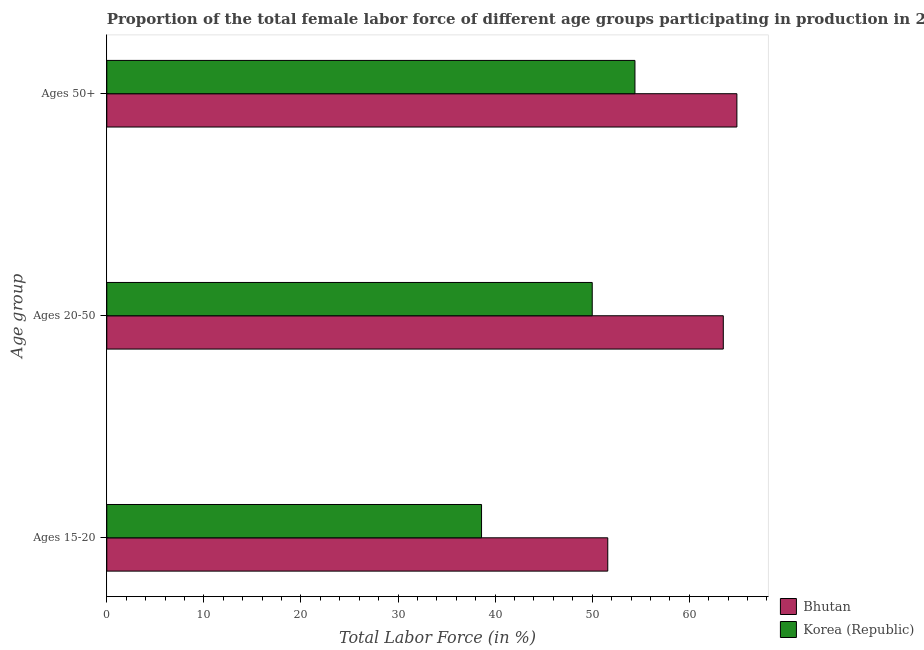How many groups of bars are there?
Your response must be concise. 3. Are the number of bars on each tick of the Y-axis equal?
Your answer should be very brief. Yes. What is the label of the 1st group of bars from the top?
Ensure brevity in your answer.  Ages 50+. What is the percentage of female labor force within the age group 20-50 in Bhutan?
Provide a succinct answer. 63.5. Across all countries, what is the maximum percentage of female labor force above age 50?
Your response must be concise. 64.9. Across all countries, what is the minimum percentage of female labor force above age 50?
Give a very brief answer. 54.4. In which country was the percentage of female labor force within the age group 15-20 maximum?
Provide a succinct answer. Bhutan. What is the total percentage of female labor force within the age group 20-50 in the graph?
Keep it short and to the point. 113.5. What is the difference between the percentage of female labor force within the age group 20-50 in Bhutan and that in Korea (Republic)?
Offer a terse response. 13.5. What is the difference between the percentage of female labor force within the age group 20-50 in Korea (Republic) and the percentage of female labor force above age 50 in Bhutan?
Make the answer very short. -14.9. What is the average percentage of female labor force above age 50 per country?
Ensure brevity in your answer.  59.65. What is the difference between the percentage of female labor force within the age group 15-20 and percentage of female labor force above age 50 in Korea (Republic)?
Make the answer very short. -15.8. What is the ratio of the percentage of female labor force within the age group 15-20 in Bhutan to that in Korea (Republic)?
Keep it short and to the point. 1.34. What is the difference between the highest and the second highest percentage of female labor force within the age group 20-50?
Offer a very short reply. 13.5. What is the difference between the highest and the lowest percentage of female labor force within the age group 15-20?
Offer a terse response. 13. Is the sum of the percentage of female labor force within the age group 20-50 in Bhutan and Korea (Republic) greater than the maximum percentage of female labor force above age 50 across all countries?
Your answer should be very brief. Yes. What does the 1st bar from the top in Ages 50+ represents?
Offer a very short reply. Korea (Republic). Are all the bars in the graph horizontal?
Ensure brevity in your answer.  Yes. How many legend labels are there?
Your response must be concise. 2. How are the legend labels stacked?
Give a very brief answer. Vertical. What is the title of the graph?
Keep it short and to the point. Proportion of the total female labor force of different age groups participating in production in 2005. Does "Palau" appear as one of the legend labels in the graph?
Provide a short and direct response. No. What is the label or title of the X-axis?
Your answer should be compact. Total Labor Force (in %). What is the label or title of the Y-axis?
Offer a terse response. Age group. What is the Total Labor Force (in %) of Bhutan in Ages 15-20?
Offer a terse response. 51.6. What is the Total Labor Force (in %) of Korea (Republic) in Ages 15-20?
Make the answer very short. 38.6. What is the Total Labor Force (in %) in Bhutan in Ages 20-50?
Keep it short and to the point. 63.5. What is the Total Labor Force (in %) in Korea (Republic) in Ages 20-50?
Provide a short and direct response. 50. What is the Total Labor Force (in %) in Bhutan in Ages 50+?
Offer a very short reply. 64.9. What is the Total Labor Force (in %) of Korea (Republic) in Ages 50+?
Offer a very short reply. 54.4. Across all Age group, what is the maximum Total Labor Force (in %) of Bhutan?
Provide a succinct answer. 64.9. Across all Age group, what is the maximum Total Labor Force (in %) in Korea (Republic)?
Keep it short and to the point. 54.4. Across all Age group, what is the minimum Total Labor Force (in %) of Bhutan?
Your response must be concise. 51.6. Across all Age group, what is the minimum Total Labor Force (in %) of Korea (Republic)?
Make the answer very short. 38.6. What is the total Total Labor Force (in %) of Bhutan in the graph?
Provide a short and direct response. 180. What is the total Total Labor Force (in %) of Korea (Republic) in the graph?
Offer a terse response. 143. What is the difference between the Total Labor Force (in %) in Bhutan in Ages 15-20 and that in Ages 20-50?
Ensure brevity in your answer.  -11.9. What is the difference between the Total Labor Force (in %) in Korea (Republic) in Ages 15-20 and that in Ages 20-50?
Make the answer very short. -11.4. What is the difference between the Total Labor Force (in %) in Bhutan in Ages 15-20 and that in Ages 50+?
Your answer should be very brief. -13.3. What is the difference between the Total Labor Force (in %) of Korea (Republic) in Ages 15-20 and that in Ages 50+?
Your response must be concise. -15.8. What is the difference between the Total Labor Force (in %) in Korea (Republic) in Ages 20-50 and that in Ages 50+?
Offer a very short reply. -4.4. What is the difference between the Total Labor Force (in %) of Bhutan in Ages 15-20 and the Total Labor Force (in %) of Korea (Republic) in Ages 50+?
Offer a very short reply. -2.8. What is the difference between the Total Labor Force (in %) of Bhutan in Ages 20-50 and the Total Labor Force (in %) of Korea (Republic) in Ages 50+?
Keep it short and to the point. 9.1. What is the average Total Labor Force (in %) in Bhutan per Age group?
Offer a terse response. 60. What is the average Total Labor Force (in %) of Korea (Republic) per Age group?
Provide a short and direct response. 47.67. What is the ratio of the Total Labor Force (in %) in Bhutan in Ages 15-20 to that in Ages 20-50?
Provide a short and direct response. 0.81. What is the ratio of the Total Labor Force (in %) in Korea (Republic) in Ages 15-20 to that in Ages 20-50?
Your answer should be very brief. 0.77. What is the ratio of the Total Labor Force (in %) of Bhutan in Ages 15-20 to that in Ages 50+?
Offer a terse response. 0.8. What is the ratio of the Total Labor Force (in %) of Korea (Republic) in Ages 15-20 to that in Ages 50+?
Provide a short and direct response. 0.71. What is the ratio of the Total Labor Force (in %) of Bhutan in Ages 20-50 to that in Ages 50+?
Make the answer very short. 0.98. What is the ratio of the Total Labor Force (in %) of Korea (Republic) in Ages 20-50 to that in Ages 50+?
Your response must be concise. 0.92. What is the difference between the highest and the second highest Total Labor Force (in %) in Bhutan?
Provide a succinct answer. 1.4. What is the difference between the highest and the second highest Total Labor Force (in %) of Korea (Republic)?
Your answer should be very brief. 4.4. What is the difference between the highest and the lowest Total Labor Force (in %) in Bhutan?
Keep it short and to the point. 13.3. What is the difference between the highest and the lowest Total Labor Force (in %) in Korea (Republic)?
Offer a terse response. 15.8. 